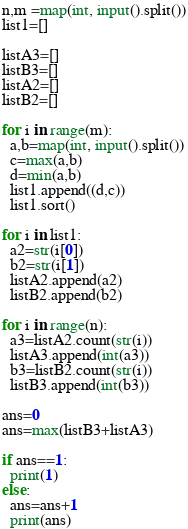<code> <loc_0><loc_0><loc_500><loc_500><_Python_>n,m =map(int, input().split())
list1=[]

listA3=[]
listB3=[]
listA2=[]
listB2=[]

for i in range(m):
  a,b=map(int, input().split())
  c=max(a,b)
  d=min(a,b)
  list1.append((d,c))
  list1.sort()

for i in list1:
  a2=str(i[0])
  b2=str(i[1])
  listA2.append(a2)
  listB2.append(b2)
  
for i in range(n):
  a3=listA2.count(str(i))
  listA3.append(int(a3))
  b3=listB2.count(str(i))
  listB3.append(int(b3))

ans=0
ans=max(listB3+listA3)

if ans==1:
  print(1)
else:
  ans=ans+1
  print(ans)</code> 